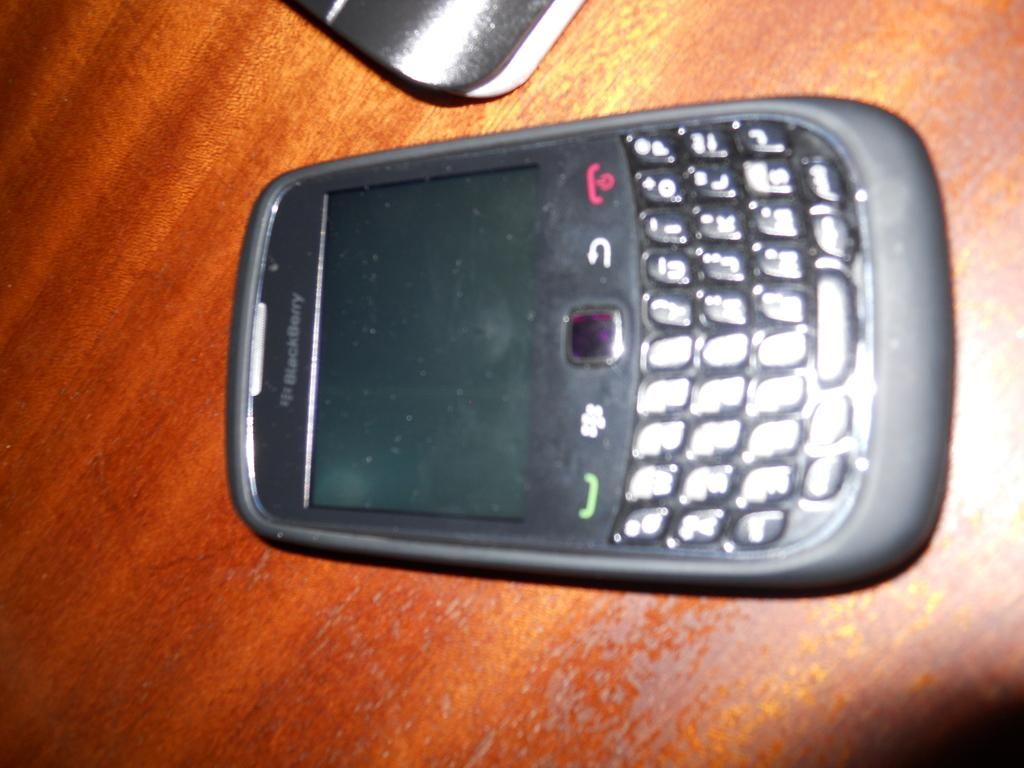<image>
Render a clear and concise summary of the photo. An older phone that says Blackberry on the top. 